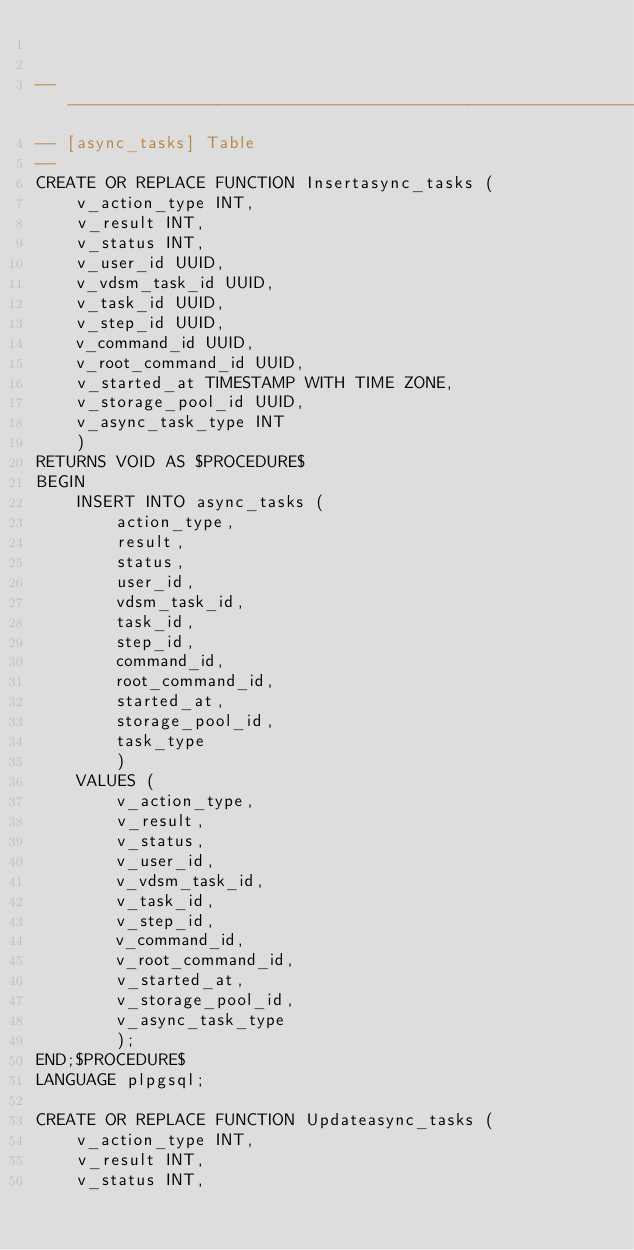<code> <loc_0><loc_0><loc_500><loc_500><_SQL_>

----------------------------------------------------------------
-- [async_tasks] Table
--
CREATE OR REPLACE FUNCTION Insertasync_tasks (
    v_action_type INT,
    v_result INT,
    v_status INT,
    v_user_id UUID,
    v_vdsm_task_id UUID,
    v_task_id UUID,
    v_step_id UUID,
    v_command_id UUID,
    v_root_command_id UUID,
    v_started_at TIMESTAMP WITH TIME ZONE,
    v_storage_pool_id UUID,
    v_async_task_type INT
    )
RETURNS VOID AS $PROCEDURE$
BEGIN
    INSERT INTO async_tasks (
        action_type,
        result,
        status,
        user_id,
        vdsm_task_id,
        task_id,
        step_id,
        command_id,
        root_command_id,
        started_at,
        storage_pool_id,
        task_type
        )
    VALUES (
        v_action_type,
        v_result,
        v_status,
        v_user_id,
        v_vdsm_task_id,
        v_task_id,
        v_step_id,
        v_command_id,
        v_root_command_id,
        v_started_at,
        v_storage_pool_id,
        v_async_task_type
        );
END;$PROCEDURE$
LANGUAGE plpgsql;

CREATE OR REPLACE FUNCTION Updateasync_tasks (
    v_action_type INT,
    v_result INT,
    v_status INT,</code> 